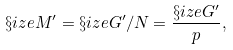Convert formula to latex. <formula><loc_0><loc_0><loc_500><loc_500>\S i z e { M ^ { \prime } } = \S i z e { { G ^ { \prime } } / { N } } = \frac { \S i z e { G ^ { \prime } } } { p } ,</formula> 